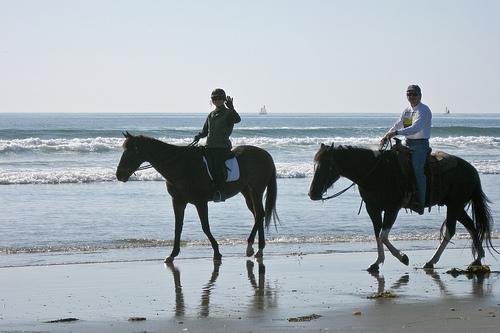How many people are shown?
Give a very brief answer. 2. 